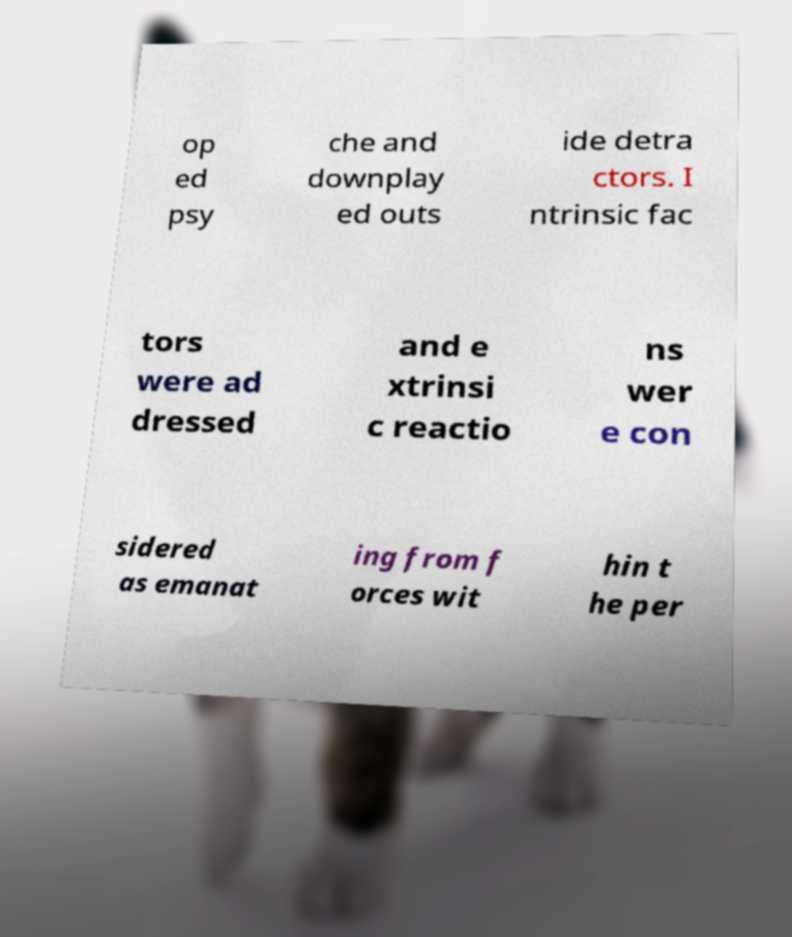Can you accurately transcribe the text from the provided image for me? op ed psy che and downplay ed outs ide detra ctors. I ntrinsic fac tors were ad dressed and e xtrinsi c reactio ns wer e con sidered as emanat ing from f orces wit hin t he per 